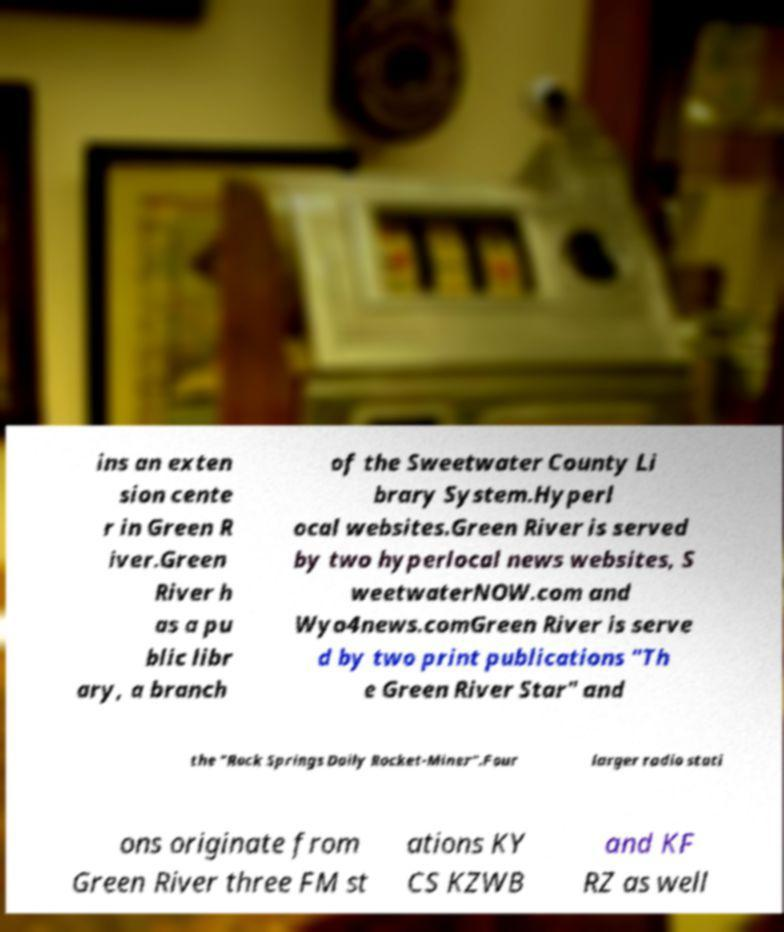Can you accurately transcribe the text from the provided image for me? ins an exten sion cente r in Green R iver.Green River h as a pu blic libr ary, a branch of the Sweetwater County Li brary System.Hyperl ocal websites.Green River is served by two hyperlocal news websites, S weetwaterNOW.com and Wyo4news.comGreen River is serve d by two print publications "Th e Green River Star" and the "Rock Springs Daily Rocket-Miner".Four larger radio stati ons originate from Green River three FM st ations KY CS KZWB and KF RZ as well 